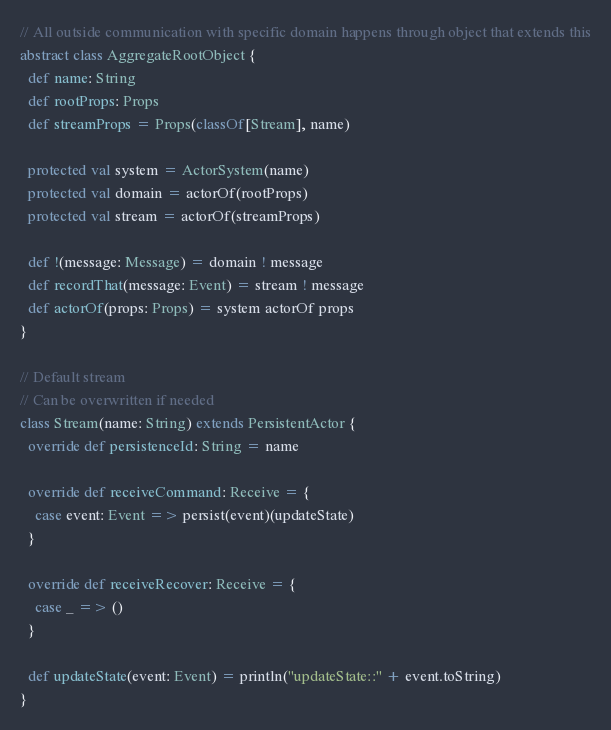<code> <loc_0><loc_0><loc_500><loc_500><_Scala_>// All outside communication with specific domain happens through object that extends this
abstract class AggregateRootObject {
  def name: String
  def rootProps: Props
  def streamProps = Props(classOf[Stream], name)

  protected val system = ActorSystem(name)
  protected val domain = actorOf(rootProps)
  protected val stream = actorOf(streamProps)

  def !(message: Message) = domain ! message
  def recordThat(message: Event) = stream ! message
  def actorOf(props: Props) = system actorOf props
}

// Default stream
// Can be overwritten if needed
class Stream(name: String) extends PersistentActor {
  override def persistenceId: String = name

  override def receiveCommand: Receive = {
    case event: Event => persist(event)(updateState)
  }

  override def receiveRecover: Receive = {
    case _ => ()
  }

  def updateState(event: Event) = println("updateState::" + event.toString)
}
</code> 